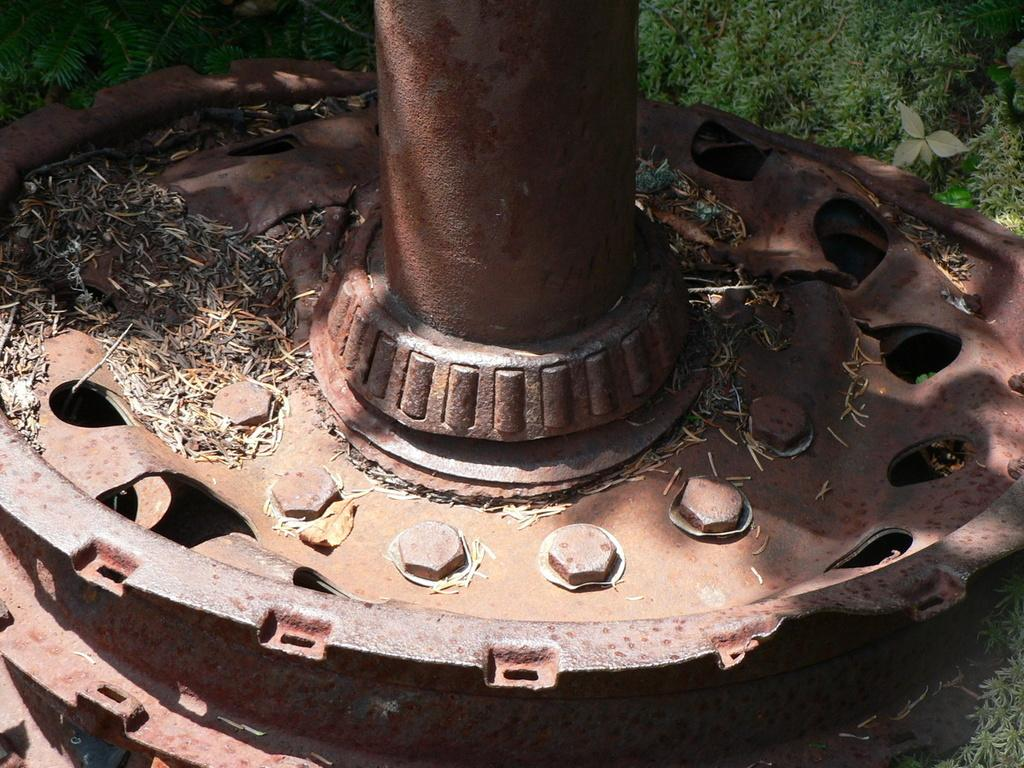What type of material is the object in the image made of? The object in the image is made of metal. What can be seen in the background of the image? There is grass visible in the background of the image. What type of leather can be seen on the pigs in the image? There are no pigs present in the image, and therefore no leather can be seen on them. What scent is associated with the metal object in the image? The image does not provide any information about the scent of the metal object, so it cannot be determined. 